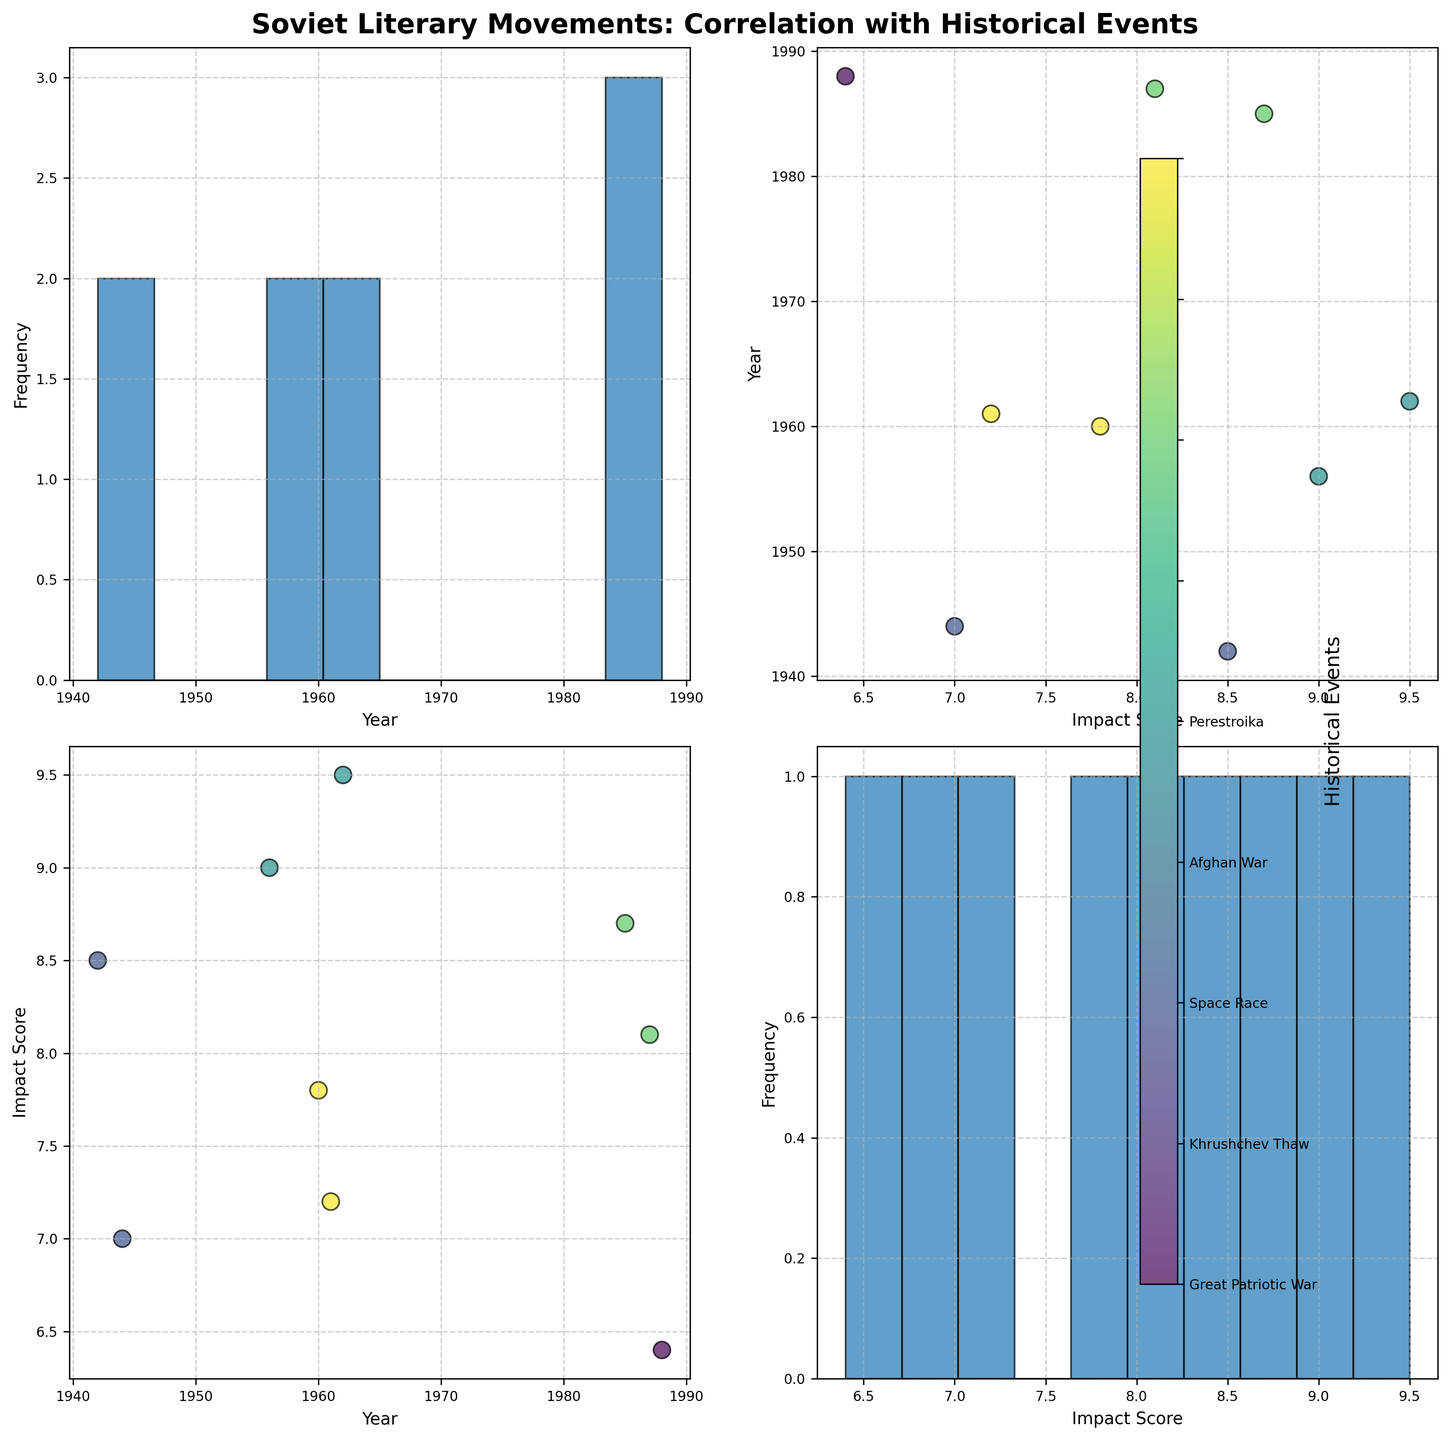How many unique historical events are represented in the scatter plot matrix? The color bar indicates different historical events. By counting the unique event labels displayed in the color bar, we find there are 5 different events.
Answer: 5 What do the diagonal plots in the scatter plot matrix represent? The diagonal plots are histograms of individual variables. The two variables in the matrix are "Year" and "Impact Score," so the diagonal plots show the distribution of these variables.
Answer: Histograms of "Year" and "Impact Score" Which historical event has the highest Impact Score, according to the scatter plot matrix? In the scatter plot of "Year" vs. "Impact Score," points are color-coded by historical events. By locating the point with the highest Impact Score (9.5), we can see it corresponds to the "Khrushchev Thaw" event.
Answer: Khrushchev Thaw Which scatter plot would you examine to identify the relationship between the publication year and the Impact Score of the literary movements? The scatter plot comparing "Year" (x-axis) and "Impact Score" (y-axis) allows us to examine the relationship between these two variables directly. This plot is found in the first row, second column.
Answer: The first row, second column plot Are there any historical events that show a trend of increasing or decreasing Impact Score over the years? By examining the scatter plot of "Year" vs. "Impact Score" and observing the color-coded points, one can look for a pattern or trend within each event group. "Khrushchev Thaw" shows high Impact Scores consistently, while "Afghan War" and "Space Race" seem to have moderate to lower scores without a clear trend.
Answer: No clear increasing or decreasing trend per event What is the range of Impact Scores in the scatter plot matrix? The range is identified by the minimum and maximum values on the "Impact Score" axis in both the scatter plot and histogram. The minimum value is around 6.4, and the maximum value is 9.5.
Answer: 6.4 to 9.5 How does the dispersion of Impact Scores compare between the Great Patriotic War and Perestroika? By observing the scatter plot "Year" vs. "Impact Score" with respective events' colors, we see that "Perestroika" has higher and more dispersed scores (8.1, 8.7) compared to the "Great Patriotic War" (7, 8.5).
Answer: Perestroika has higher and more dispersed scores Is there any observable clustering of data points based on historical events in the scatter plots? In the scatter plots, clusters can be identified by color coding. For example, "Khrushchev Thaw" shows clustering around high Impact Scores (9, 9.5) in the early 1960s, while other events like the "Great Patriotic War" and "Afghan War" have points spread out.
Answer: Yes, clustering is observable Do the histograms on the diagonal indicate a single predominant value for Impact Scores? The histogram for "Impact Score" on the diagonal plots shows multiple peaks, indicating a range of predominant scores rather than a single value.
Answer: No, multiple peaks 